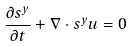<formula> <loc_0><loc_0><loc_500><loc_500>\frac { \partial s ^ { y } } { \partial t } + \nabla \cdot s ^ { y } { u } = 0</formula> 